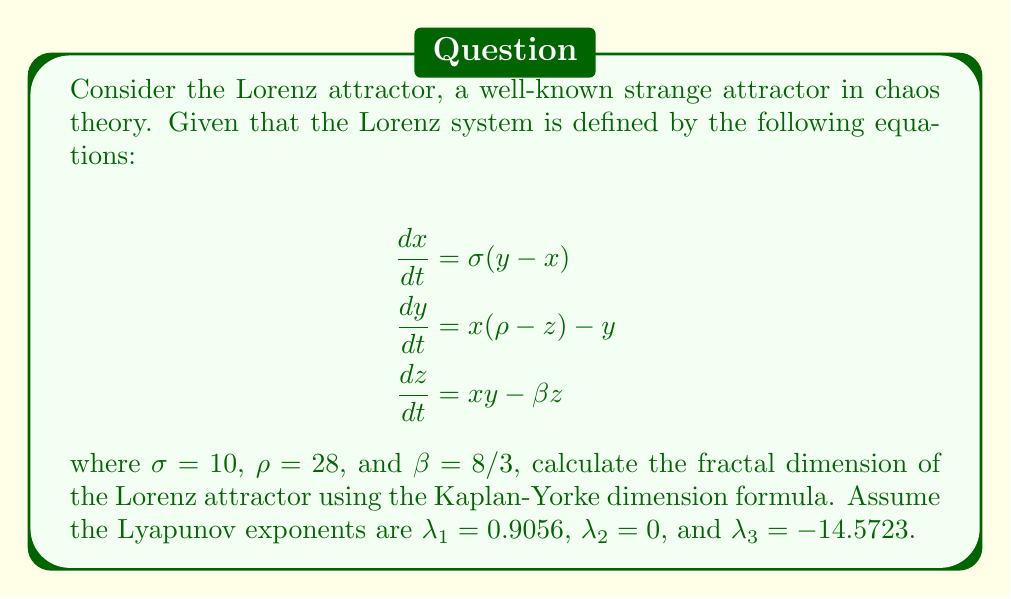What is the answer to this math problem? To calculate the fractal dimension of the Lorenz attractor using the Kaplan-Yorke dimension formula, we'll follow these steps:

1. Recall the Kaplan-Yorke dimension formula:

   $D_{KY} = j + \frac{\sum_{i=1}^j \lambda_i}{|\lambda_{j+1}|}$

   where $j$ is the largest integer such that $\sum_{i=1}^j \lambda_i \geq 0$.

2. Order the Lyapunov exponents from largest to smallest:
   $\lambda_1 = 0.9056$, $\lambda_2 = 0$, $\lambda_3 = -14.5723$

3. Find $j$:
   $\lambda_1 + \lambda_2 = 0.9056 + 0 = 0.9056 > 0$
   $\lambda_1 + \lambda_2 + \lambda_3 = 0.9056 + 0 - 14.5723 = -13.6667 < 0$
   Therefore, $j = 2$

4. Calculate the sum of the first $j$ Lyapunov exponents:
   $\sum_{i=1}^j \lambda_i = \lambda_1 + \lambda_2 = 0.9056 + 0 = 0.9056$

5. Apply the Kaplan-Yorke dimension formula:

   $D_{KY} = 2 + \frac{0.9056}{|-14.5723|} = 2 + 0.0621 = 2.0621$

Thus, the fractal dimension of the Lorenz attractor is approximately 2.0621.
Answer: $2.0621$ 